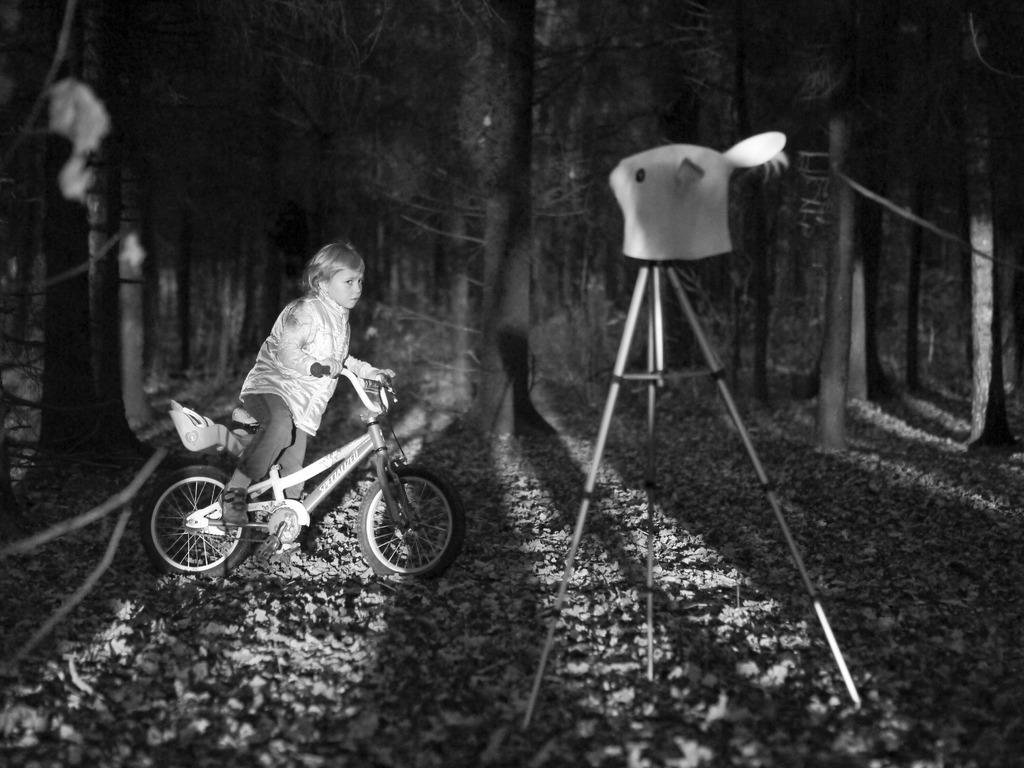What is the color scheme of the image? The image is black and white. What can be seen at the top of the image? There are trees at the top of the image. What is located at the bottom of the image? There are stones at the bottom of the image. What is in the middle of the image? There is a camera stand in the middle of the image. What type of vehicle is present in the image? There is a bicycle in the image. Who is sitting on the bicycle? A kid is sitting on the bicycle. What type of soup is being prepared in the image? There is no soup present in the image; it is a black and white image featuring trees, stones, a camera stand, a bicycle, and a kid sitting on the bicycle. 